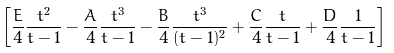Convert formula to latex. <formula><loc_0><loc_0><loc_500><loc_500>\left [ \frac { E } { 4 } \frac { t ^ { 2 } } { t - 1 } - \frac { A } { 4 } \frac { t ^ { 3 } } { t - 1 } - \frac { B } { 4 } \frac { t ^ { 3 } } { ( t - 1 ) ^ { 2 } } + \frac { C } { 4 } \frac { t } { t - 1 } + \frac { D } { 4 } \frac { 1 } { t - 1 } \right ]</formula> 